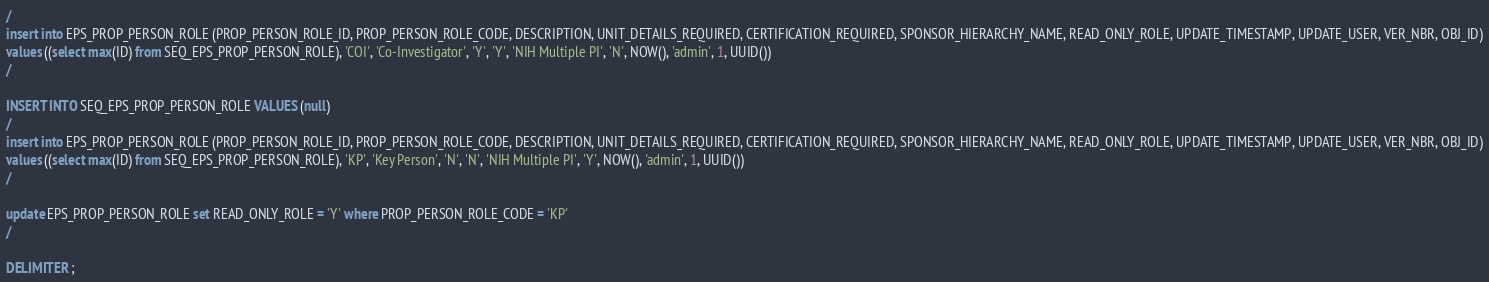Convert code to text. <code><loc_0><loc_0><loc_500><loc_500><_SQL_>/
insert into EPS_PROP_PERSON_ROLE (PROP_PERSON_ROLE_ID, PROP_PERSON_ROLE_CODE, DESCRIPTION, UNIT_DETAILS_REQUIRED, CERTIFICATION_REQUIRED, SPONSOR_HIERARCHY_NAME, READ_ONLY_ROLE, UPDATE_TIMESTAMP, UPDATE_USER, VER_NBR, OBJ_ID)
values ((select max(ID) from SEQ_EPS_PROP_PERSON_ROLE), 'COI', 'Co-Investigator', 'Y', 'Y', 'NIH Multiple PI', 'N', NOW(), 'admin', 1, UUID())
/

INSERT INTO SEQ_EPS_PROP_PERSON_ROLE VALUES (null)
/
insert into EPS_PROP_PERSON_ROLE (PROP_PERSON_ROLE_ID, PROP_PERSON_ROLE_CODE, DESCRIPTION, UNIT_DETAILS_REQUIRED, CERTIFICATION_REQUIRED, SPONSOR_HIERARCHY_NAME, READ_ONLY_ROLE, UPDATE_TIMESTAMP, UPDATE_USER, VER_NBR, OBJ_ID)
values ((select max(ID) from SEQ_EPS_PROP_PERSON_ROLE), 'KP', 'Key Person', 'N', 'N', 'NIH Multiple PI', 'Y', NOW(), 'admin', 1, UUID())
/

update EPS_PROP_PERSON_ROLE set READ_ONLY_ROLE = 'Y' where PROP_PERSON_ROLE_CODE = 'KP'
/

DELIMITER ;
</code> 